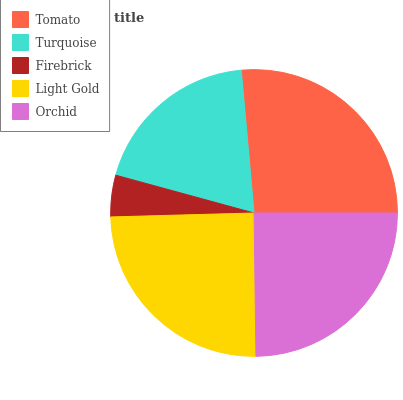Is Firebrick the minimum?
Answer yes or no. Yes. Is Tomato the maximum?
Answer yes or no. Yes. Is Turquoise the minimum?
Answer yes or no. No. Is Turquoise the maximum?
Answer yes or no. No. Is Tomato greater than Turquoise?
Answer yes or no. Yes. Is Turquoise less than Tomato?
Answer yes or no. Yes. Is Turquoise greater than Tomato?
Answer yes or no. No. Is Tomato less than Turquoise?
Answer yes or no. No. Is Light Gold the high median?
Answer yes or no. Yes. Is Light Gold the low median?
Answer yes or no. Yes. Is Tomato the high median?
Answer yes or no. No. Is Tomato the low median?
Answer yes or no. No. 